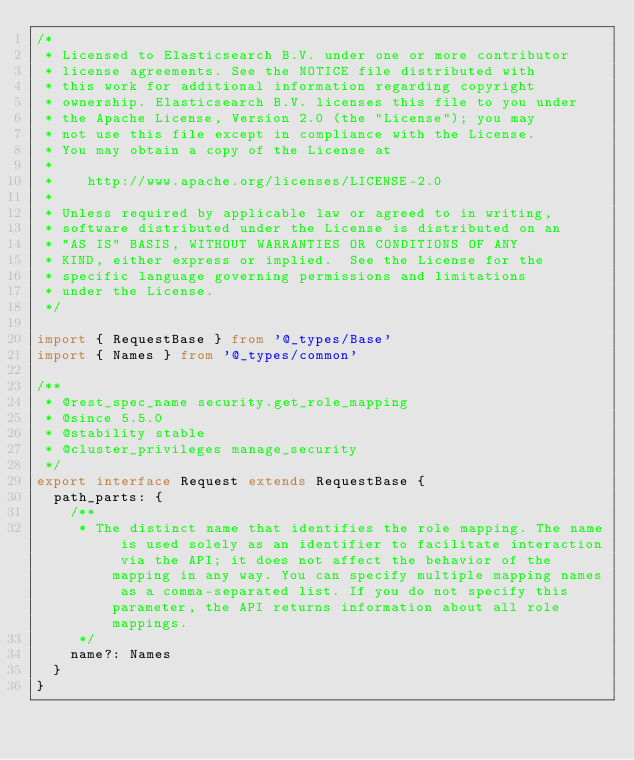<code> <loc_0><loc_0><loc_500><loc_500><_TypeScript_>/*
 * Licensed to Elasticsearch B.V. under one or more contributor
 * license agreements. See the NOTICE file distributed with
 * this work for additional information regarding copyright
 * ownership. Elasticsearch B.V. licenses this file to you under
 * the Apache License, Version 2.0 (the "License"); you may
 * not use this file except in compliance with the License.
 * You may obtain a copy of the License at
 *
 *    http://www.apache.org/licenses/LICENSE-2.0
 *
 * Unless required by applicable law or agreed to in writing,
 * software distributed under the License is distributed on an
 * "AS IS" BASIS, WITHOUT WARRANTIES OR CONDITIONS OF ANY
 * KIND, either express or implied.  See the License for the
 * specific language governing permissions and limitations
 * under the License.
 */

import { RequestBase } from '@_types/Base'
import { Names } from '@_types/common'

/**
 * @rest_spec_name security.get_role_mapping
 * @since 5.5.0
 * @stability stable
 * @cluster_privileges manage_security
 */
export interface Request extends RequestBase {
  path_parts: {
    /**
     * The distinct name that identifies the role mapping. The name is used solely as an identifier to facilitate interaction via the API; it does not affect the behavior of the mapping in any way. You can specify multiple mapping names as a comma-separated list. If you do not specify this parameter, the API returns information about all role mappings.
     */
    name?: Names
  }
}
</code> 